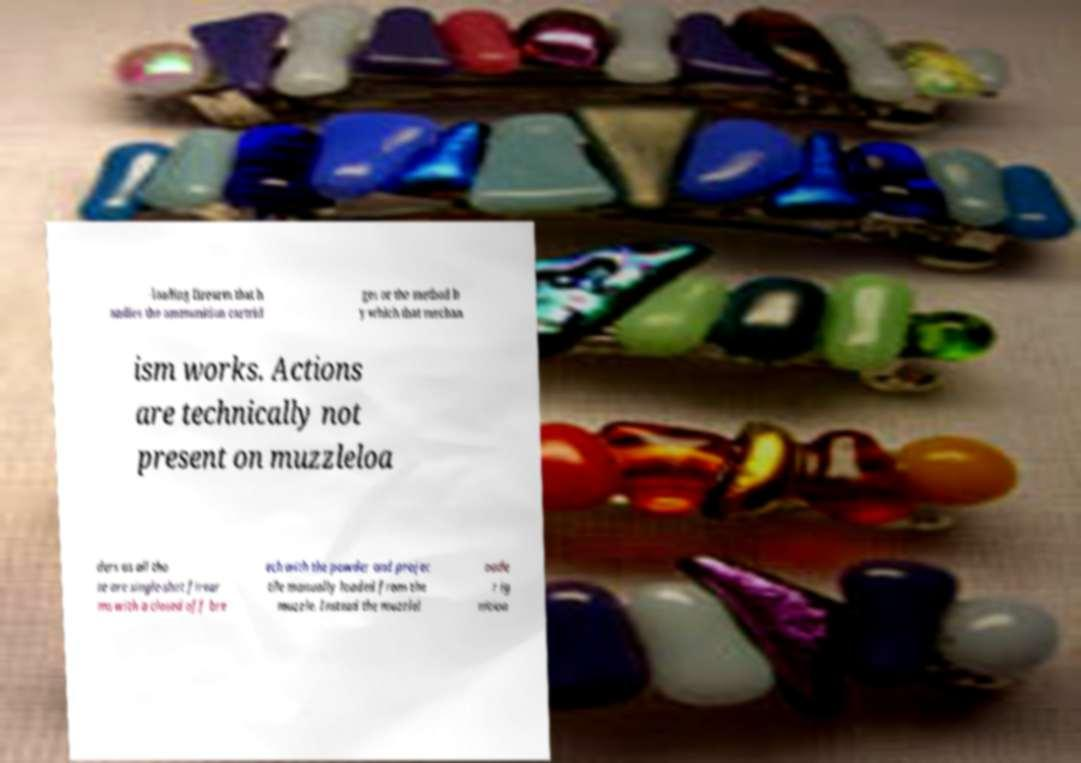What messages or text are displayed in this image? I need them in a readable, typed format. -loading firearm that h andles the ammunition cartrid ges or the method b y which that mechan ism works. Actions are technically not present on muzzleloa ders as all tho se are single-shot firear ms with a closed off bre ech with the powder and projec tile manually loaded from the muzzle. Instead the muzzlel oade r ig nition 